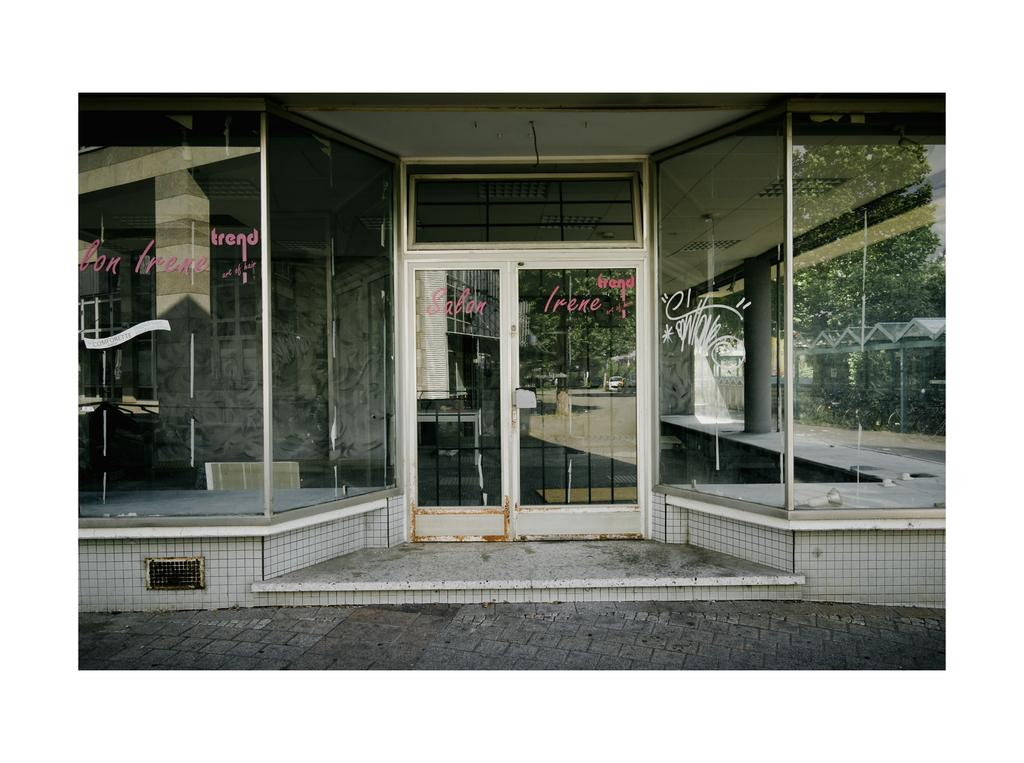What type of structure is present in the image? There is a building in the image. What feature can be found on the building? There are doors on the building. What other objects can be seen in the image? There are poles and trees in the image. What additional structure is present in the image? There is a shed in the image. What information is visible on the doors? There is text visible on the doors. What type of seat can be seen in the image? There is no seat present in the image. What type of writing is visible on the trees? There is no writing visible on the trees; only text is present on the doors. 